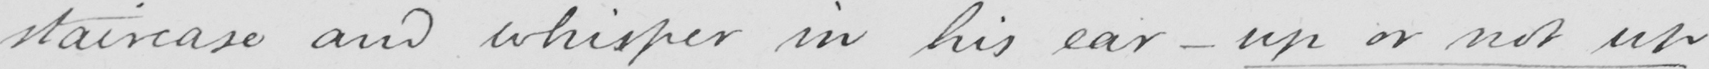Please provide the text content of this handwritten line. staircase and whisper in his ear -up or not up 